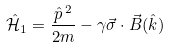Convert formula to latex. <formula><loc_0><loc_0><loc_500><loc_500>\hat { \mathcal { H } } _ { 1 } = \frac { \hat { p } ^ { \text { } 2 } } { 2 m } - \gamma \vec { \sigma } \cdot \vec { B } ( \hat { k } )</formula> 